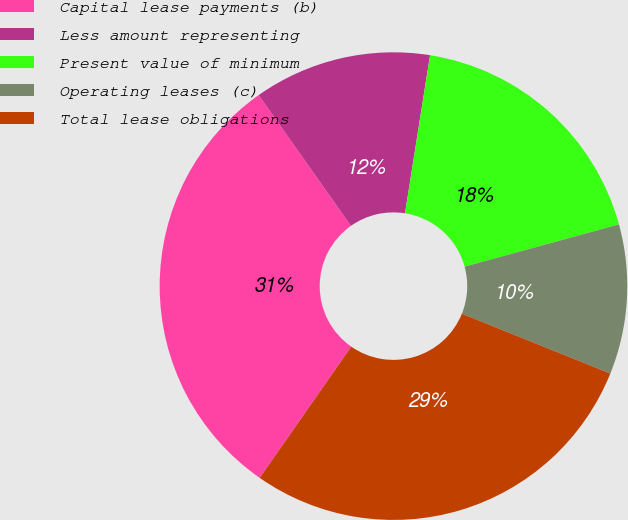<chart> <loc_0><loc_0><loc_500><loc_500><pie_chart><fcel>Capital lease payments (b)<fcel>Less amount representing<fcel>Present value of minimum<fcel>Operating leases (c)<fcel>Total lease obligations<nl><fcel>30.53%<fcel>12.28%<fcel>18.25%<fcel>10.35%<fcel>28.6%<nl></chart> 